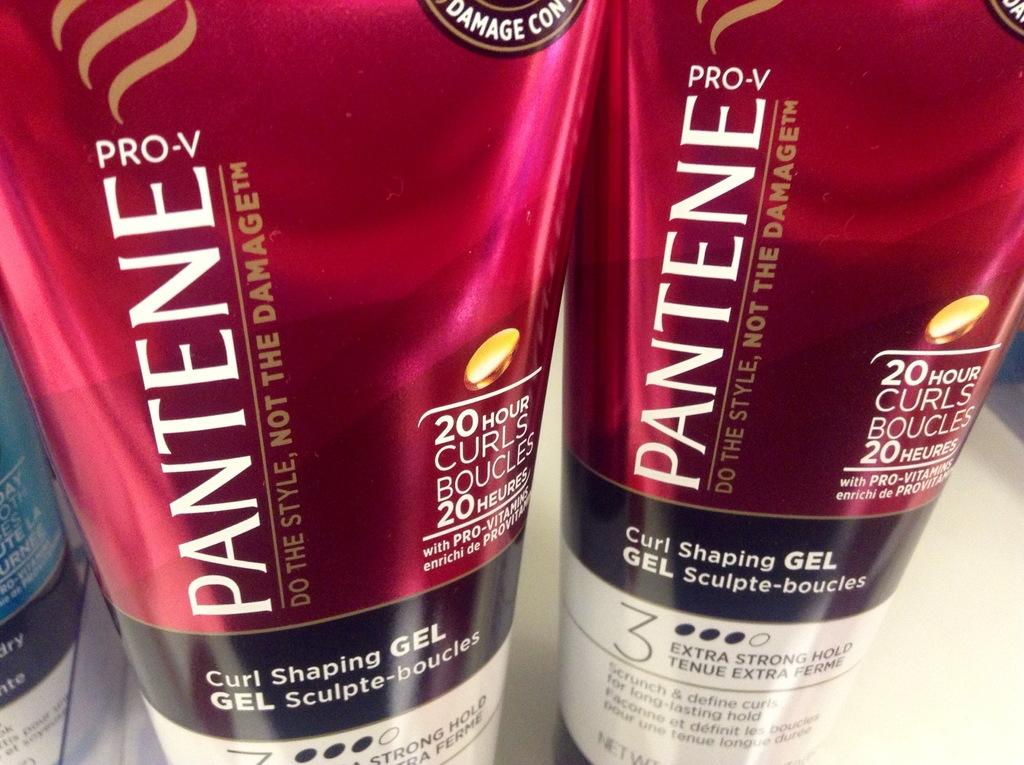<image>
Offer a succinct explanation of the picture presented. A couple Pantene brand curl shaping gel product container 